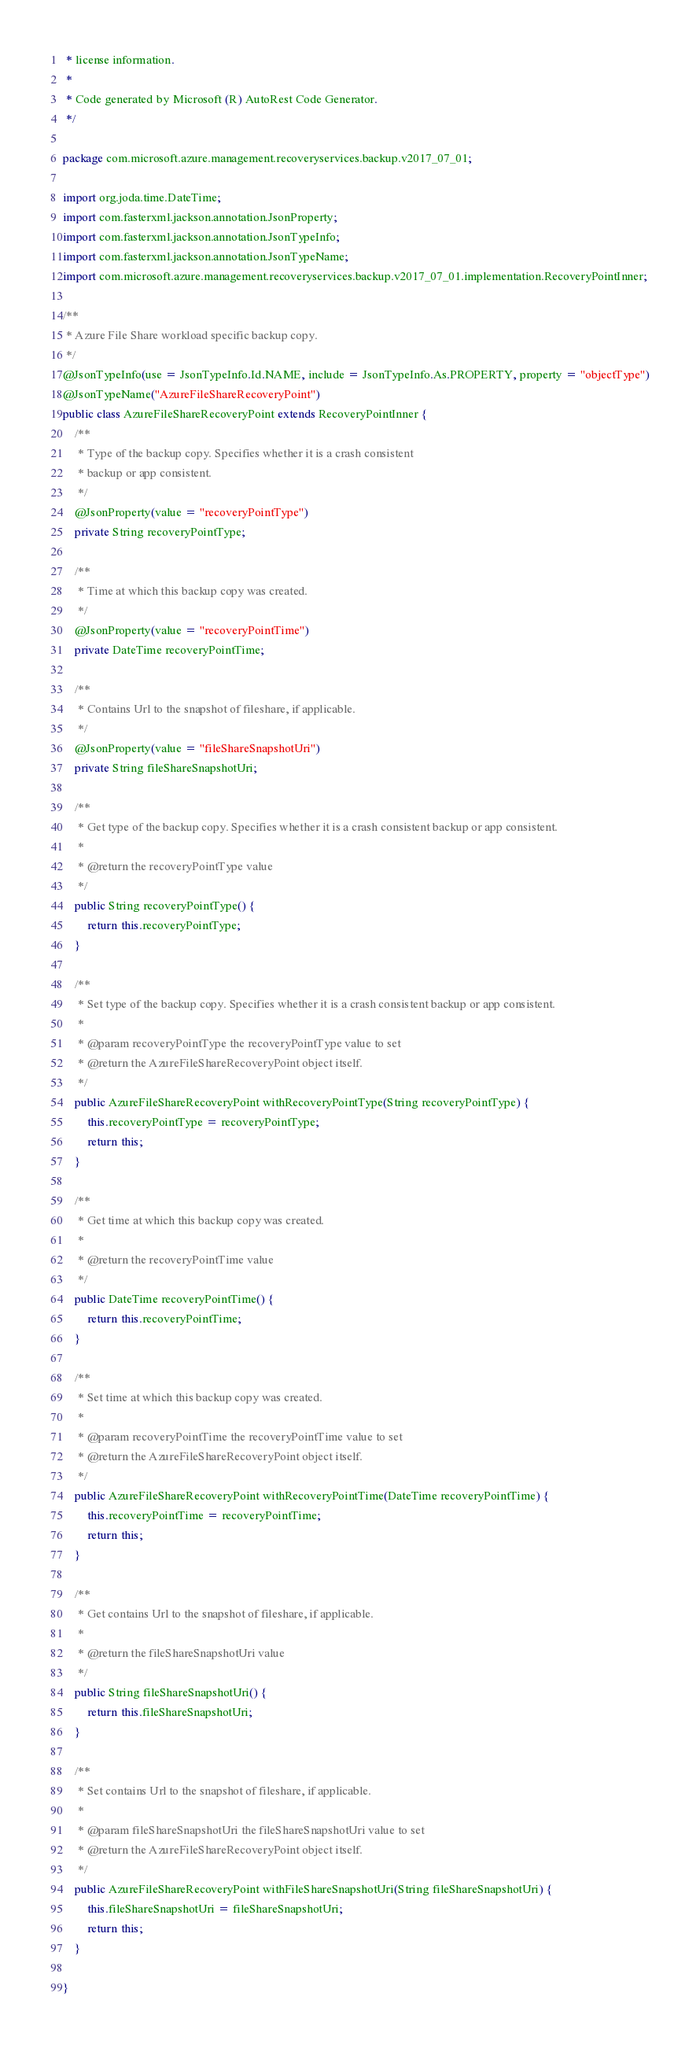<code> <loc_0><loc_0><loc_500><loc_500><_Java_> * license information.
 *
 * Code generated by Microsoft (R) AutoRest Code Generator.
 */

package com.microsoft.azure.management.recoveryservices.backup.v2017_07_01;

import org.joda.time.DateTime;
import com.fasterxml.jackson.annotation.JsonProperty;
import com.fasterxml.jackson.annotation.JsonTypeInfo;
import com.fasterxml.jackson.annotation.JsonTypeName;
import com.microsoft.azure.management.recoveryservices.backup.v2017_07_01.implementation.RecoveryPointInner;

/**
 * Azure File Share workload specific backup copy.
 */
@JsonTypeInfo(use = JsonTypeInfo.Id.NAME, include = JsonTypeInfo.As.PROPERTY, property = "objectType")
@JsonTypeName("AzureFileShareRecoveryPoint")
public class AzureFileShareRecoveryPoint extends RecoveryPointInner {
    /**
     * Type of the backup copy. Specifies whether it is a crash consistent
     * backup or app consistent.
     */
    @JsonProperty(value = "recoveryPointType")
    private String recoveryPointType;

    /**
     * Time at which this backup copy was created.
     */
    @JsonProperty(value = "recoveryPointTime")
    private DateTime recoveryPointTime;

    /**
     * Contains Url to the snapshot of fileshare, if applicable.
     */
    @JsonProperty(value = "fileShareSnapshotUri")
    private String fileShareSnapshotUri;

    /**
     * Get type of the backup copy. Specifies whether it is a crash consistent backup or app consistent.
     *
     * @return the recoveryPointType value
     */
    public String recoveryPointType() {
        return this.recoveryPointType;
    }

    /**
     * Set type of the backup copy. Specifies whether it is a crash consistent backup or app consistent.
     *
     * @param recoveryPointType the recoveryPointType value to set
     * @return the AzureFileShareRecoveryPoint object itself.
     */
    public AzureFileShareRecoveryPoint withRecoveryPointType(String recoveryPointType) {
        this.recoveryPointType = recoveryPointType;
        return this;
    }

    /**
     * Get time at which this backup copy was created.
     *
     * @return the recoveryPointTime value
     */
    public DateTime recoveryPointTime() {
        return this.recoveryPointTime;
    }

    /**
     * Set time at which this backup copy was created.
     *
     * @param recoveryPointTime the recoveryPointTime value to set
     * @return the AzureFileShareRecoveryPoint object itself.
     */
    public AzureFileShareRecoveryPoint withRecoveryPointTime(DateTime recoveryPointTime) {
        this.recoveryPointTime = recoveryPointTime;
        return this;
    }

    /**
     * Get contains Url to the snapshot of fileshare, if applicable.
     *
     * @return the fileShareSnapshotUri value
     */
    public String fileShareSnapshotUri() {
        return this.fileShareSnapshotUri;
    }

    /**
     * Set contains Url to the snapshot of fileshare, if applicable.
     *
     * @param fileShareSnapshotUri the fileShareSnapshotUri value to set
     * @return the AzureFileShareRecoveryPoint object itself.
     */
    public AzureFileShareRecoveryPoint withFileShareSnapshotUri(String fileShareSnapshotUri) {
        this.fileShareSnapshotUri = fileShareSnapshotUri;
        return this;
    }

}
</code> 